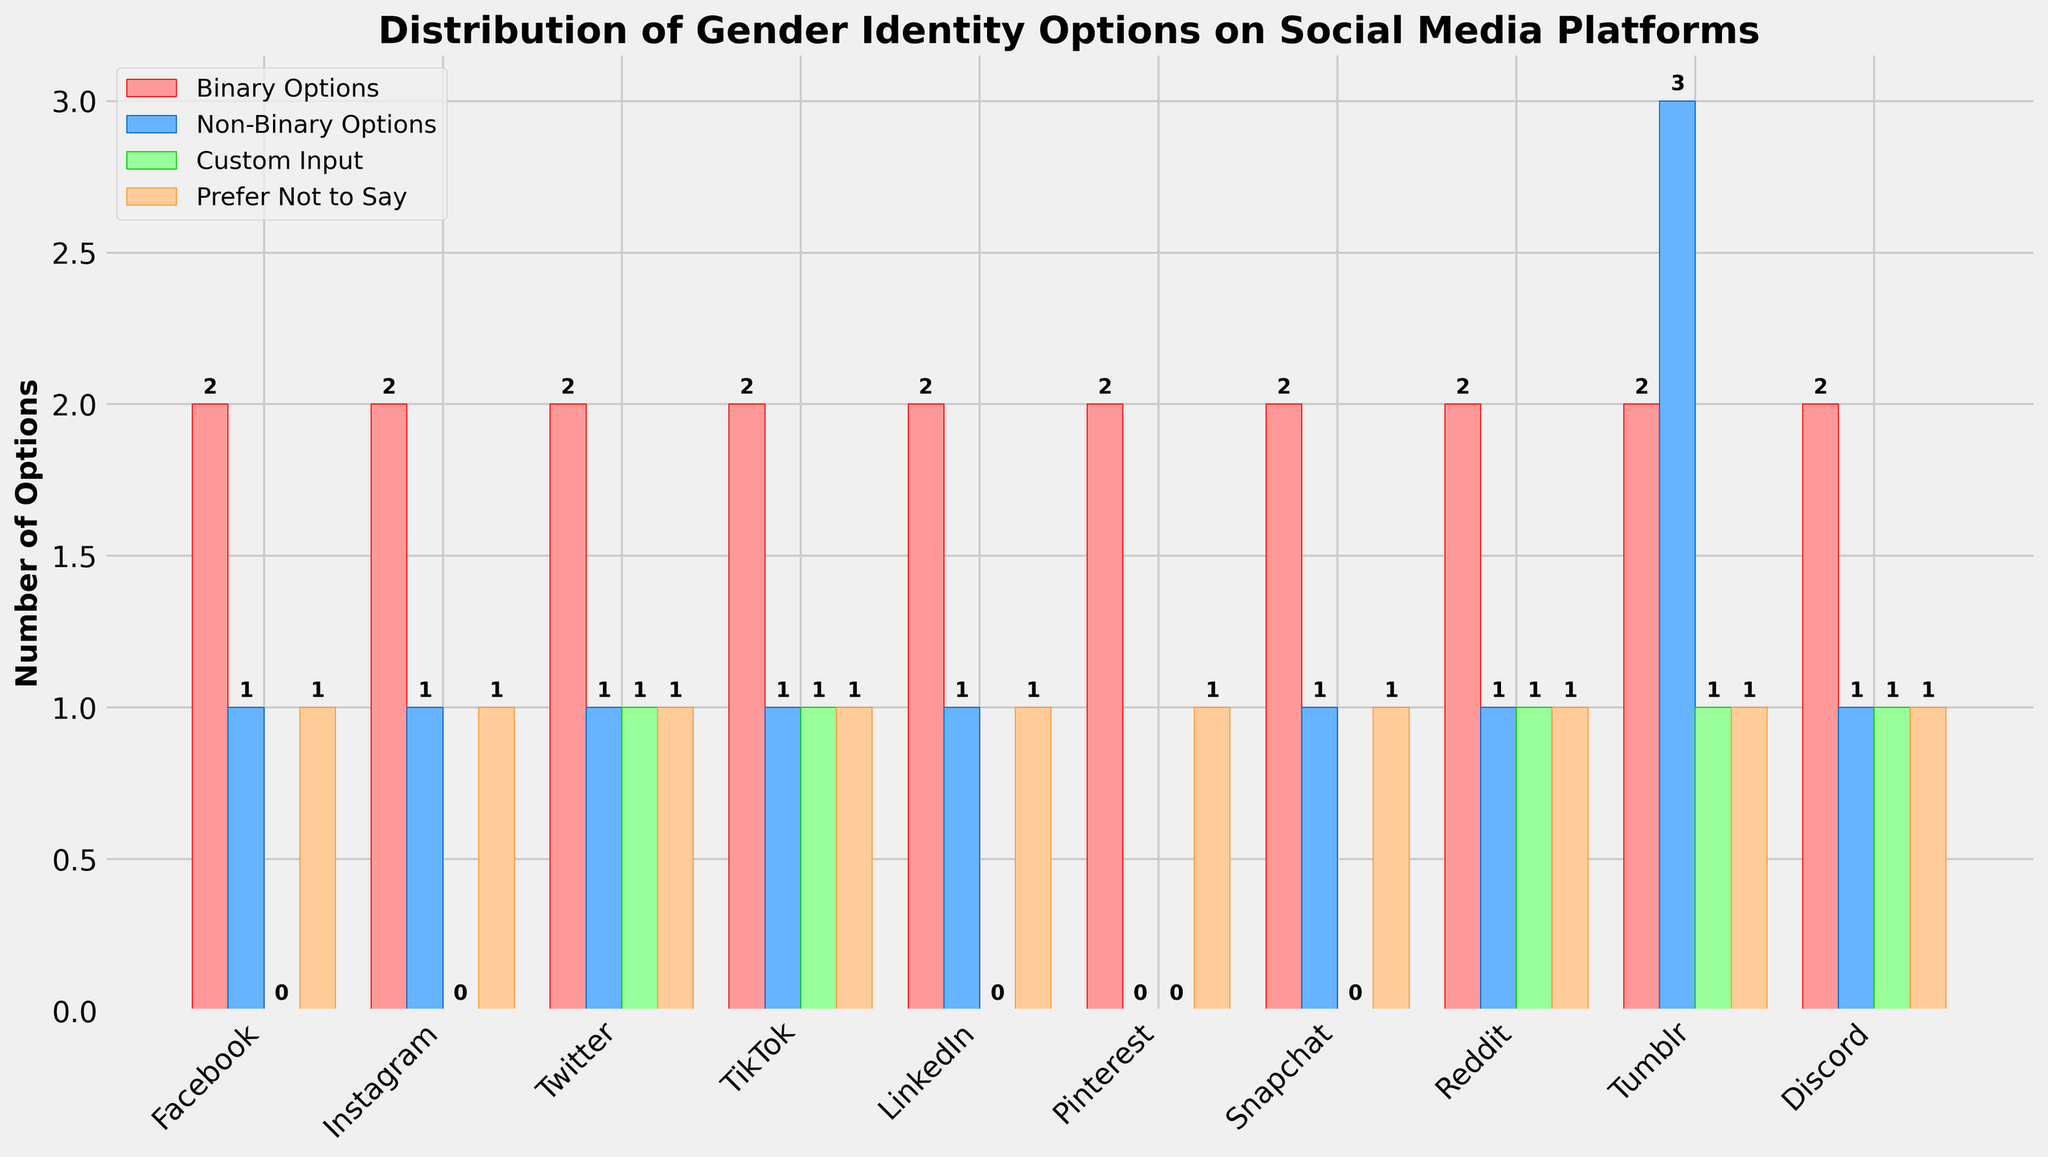Which platform offers the most options for non-binary users? Examination of the bar chart reveals that Tumblr has the highest number of non-binary options (3), as the corresponding blue bar for Tumblr is the tallest under the "Non-Binary Options" category.
Answer: Tumblr How many platforms offer the ability to input a custom gender option? The bars representing "Custom Input" (green) for Twitter, TikTok, Reddit, Tumblr, and Discord each have a height of 1. Counting these platforms gives us a total of 5.
Answer: 5 Which two platforms offer the least number of choices for non-binary users? The bar chart shows all platforms except Pinterest offer at least 1 non-binary option as indicated by the height of the blue bars. Therefore, Pinterest, with a blue bar height of 0, offers the least (zero) non-binary options. Pinterest is alone in this regard.
Answer: Pinterest Which platforms have the same distribution of gender identity options across all categories? Observation of the bar heights reveals that Facebook, Instagram, LinkedIn, Snapchat each have a red bar for binary options (height 2), a blue bar for non-binary options (height 1), no green bar for custom input (height 0), and an orange bar for prefer not to say (height 1), making their distributions the same.
Answer: Facebook, Instagram, LinkedIn, Snapchat On average, how many platforms allow a custom input option? Summing the green bar heights for all platforms gives 6 (Twitter, TikTok, Reddit, Tumblr, Discord). There are 10 platforms. The average is calculated as 6/10 = 0.6.
Answer: 0.6 Which platforms offer exactly one option each for non-binary and prefer not to say categories but no option for custom input? By examining the non-binary, prefer not to say, and custom input bars, Instagram, Facebook, LinkedIn, Snapchat each show a blue bar height of 1, an orange bar height of 1, and a green bar height of 0.
Answer: Instagram, Facebook, LinkedIn, Snapchat How many total gender identity options does Tumblr offer across all categories? Checking the bar values for Tumblr: Binary Options (2), Non-Binary Options (3), Custom Input (1), Prefer Not to Say (1). Adding these together yields 2 + 3 + 1 + 1 = 7.
Answer: 7 Which platform provides the most limited options for gender identity? The heights of the bars for Pinterest show: Binary Options (2), Non-Binary Options (0), Custom Input (0), Prefer Not to Say (1). The number of options (3) is the lowest compared with others.
Answer: Pinterest What's the difference in the number of custom input options between Tumblr and Snapchat? Tumblr and Snapchat's corresponding green bars (custom input) show heights of 1 and 0, respectively. The difference is 1 - 0 = 1.
Answer: 1 